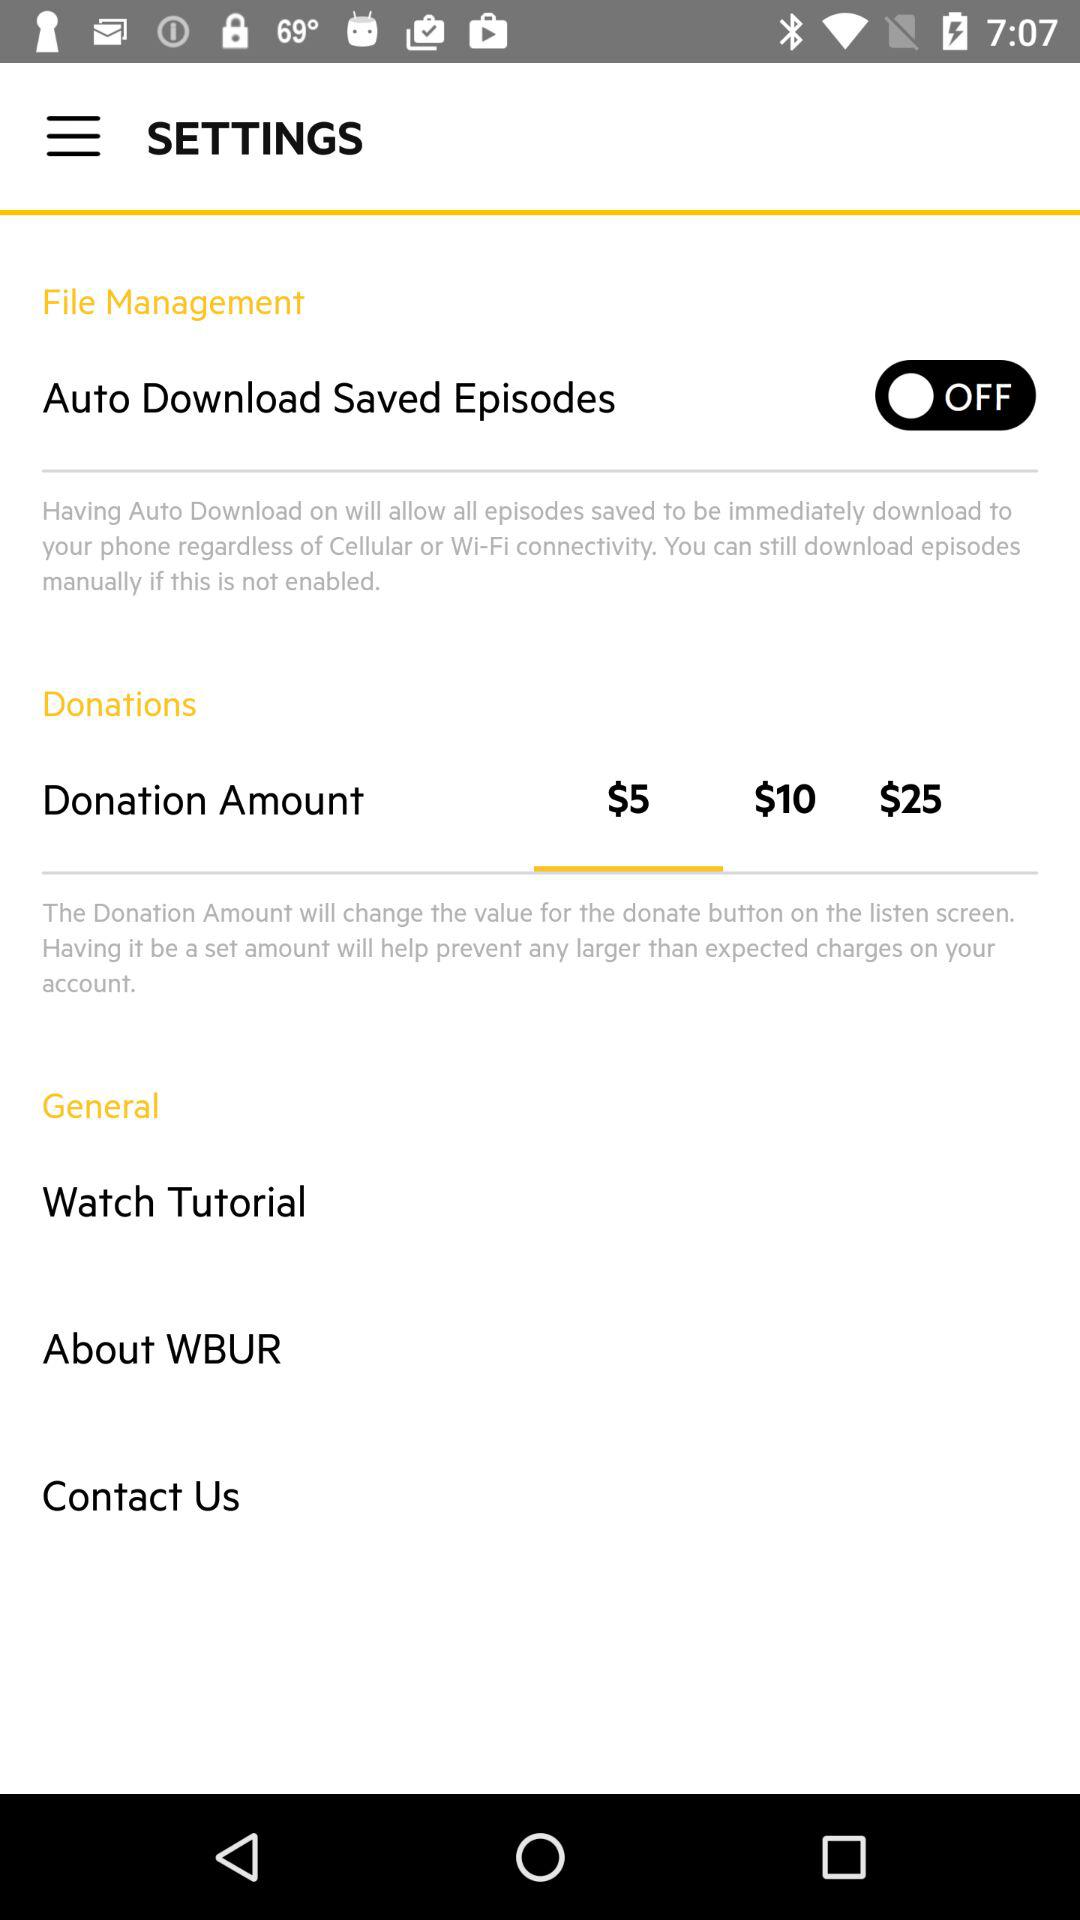How many donation amount options are there?
Answer the question using a single word or phrase. 3 